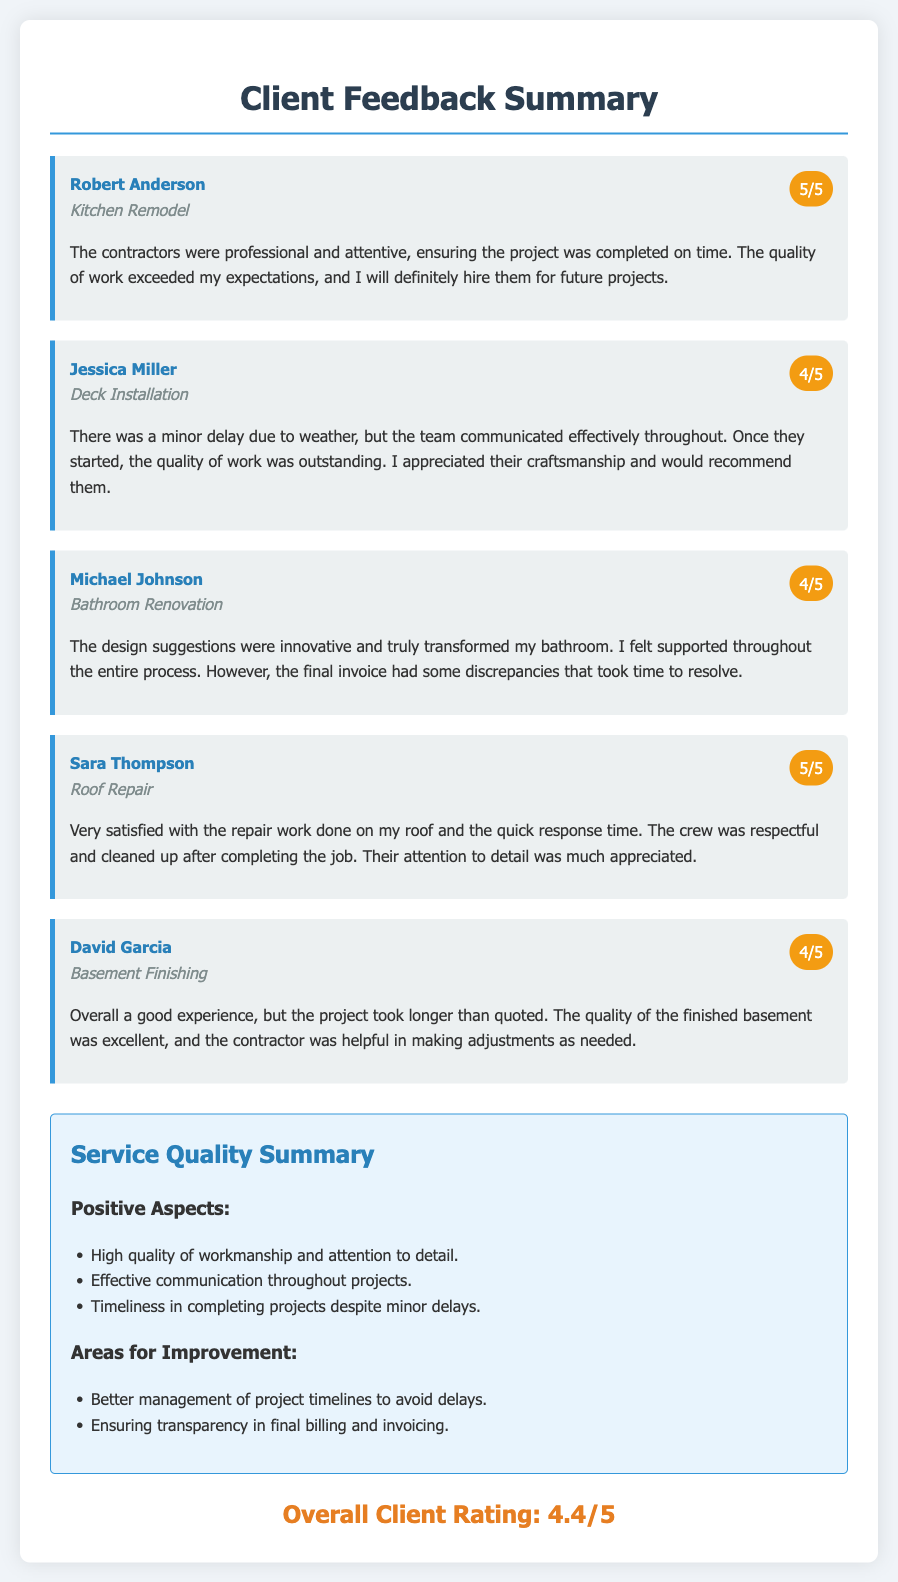What is the overall client rating? The overall client rating is given at the end of the summary, which is calculated from the individual feedback ratings.
Answer: 4.4/5 Who provided feedback for the Kitchen Remodel? The feedback for the Kitchen Remodel was given by a specific client, whose name is mentioned in the document.
Answer: Robert Anderson What is one positive aspect highlighted in the service quality summary? Positive aspects are outlined in the summary section, mentioning specific strengths of the service.
Answer: High quality of workmanship and attention to detail Which client mentioned discrepancies in the final invoice? The client who had issues with the final invoice is noted in the feedback section with their specific project details.
Answer: Michael Johnson How many clients rated their service 5 out of 5? The number of clients who rated their experience as perfect is noted in the feedback section.
Answer: 2 What was the reason for the minor delay in the Deck Installation? A specific reason for the delay is provided by the client who experienced this issue.
Answer: Weather What project did David Garcia have completed? The specific project completed for David Garcia is noted in the client feedback section.
Answer: Basement Finishing What did Sara Thompson appreciate about the crew? The feedback provides a specific detail that the client valued regarding the crew's conduct during the project.
Answer: Cleaned up after completing the job What is one area for improvement mentioned in the summary? The summary section lists areas that the service could improve upon based on client feedback.
Answer: Better management of project timelines to avoid delays 